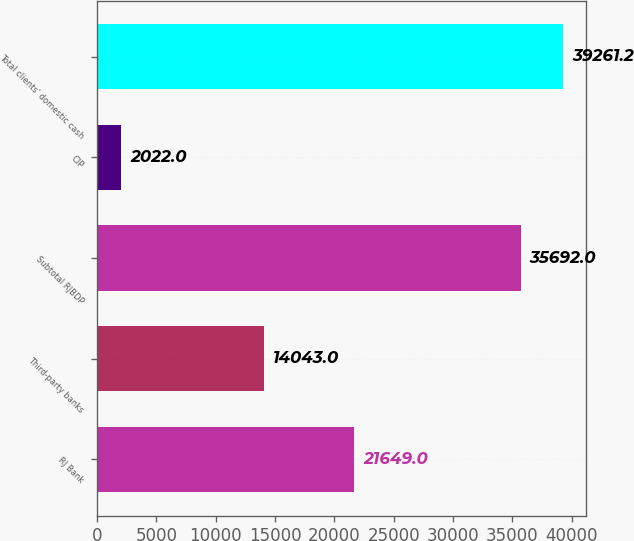Convert chart. <chart><loc_0><loc_0><loc_500><loc_500><bar_chart><fcel>RJ Bank<fcel>Third-party banks<fcel>Subtotal RJBDP<fcel>CIP<fcel>Total clients' domestic cash<nl><fcel>21649<fcel>14043<fcel>35692<fcel>2022<fcel>39261.2<nl></chart> 